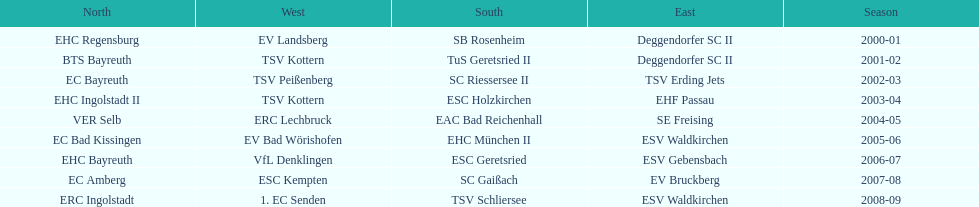What is the number of seasons covered in the table? 9. 